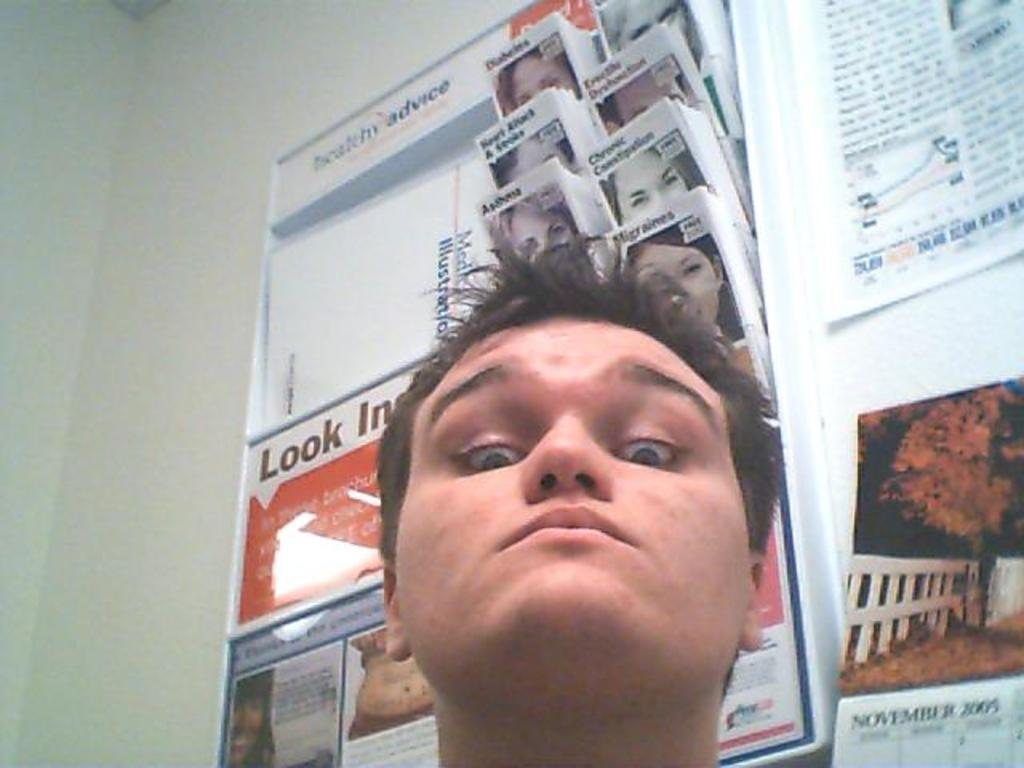Who is present in the image? There is a man in the image. What can be seen on the wall in the image? There are posters on the wall with text. What is the purpose of the paper stand in the image? There are papers in a paper stand, which suggests they are meant to be read or referenced. What type of attack is being carried out in the image? There is no attack present in the image; it features a man, posters on the wall, and papers in a paper stand. Is there any water visible in the image? There is no water present in the image. 